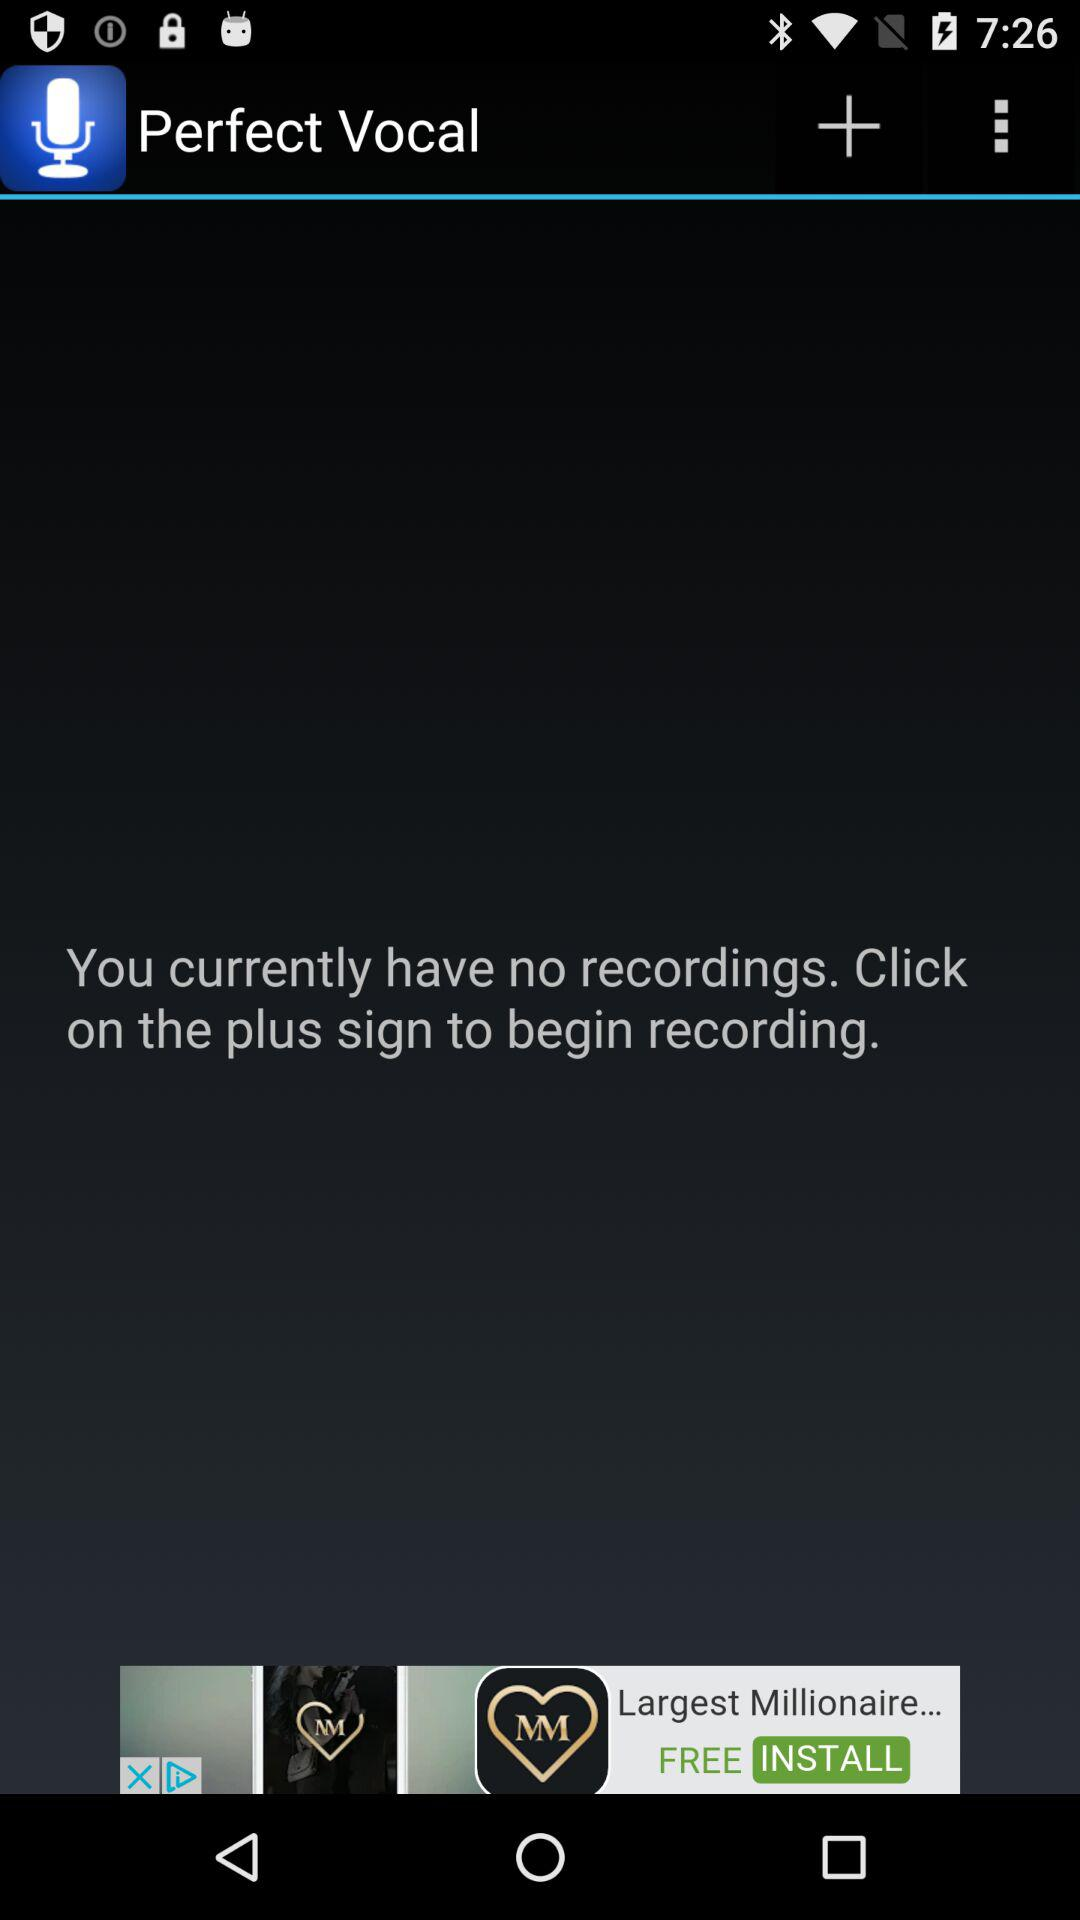What is the application name? The application name is "Perfect Vocal". 